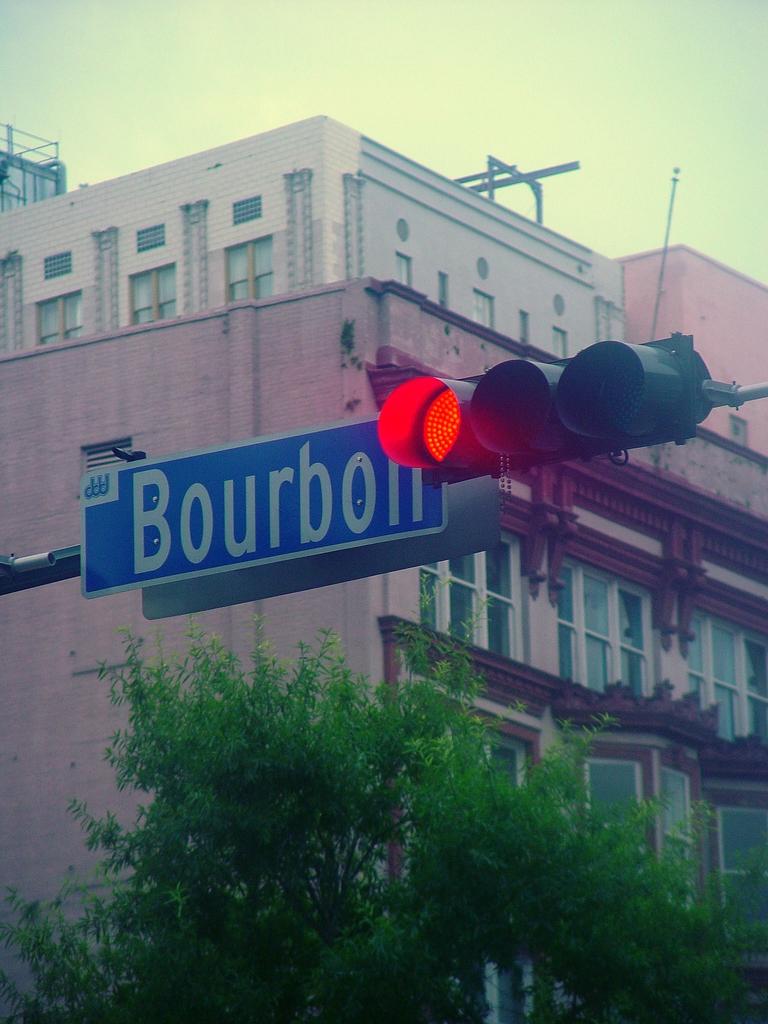What is written on the blue sign?
Your response must be concise. Bourbon. 